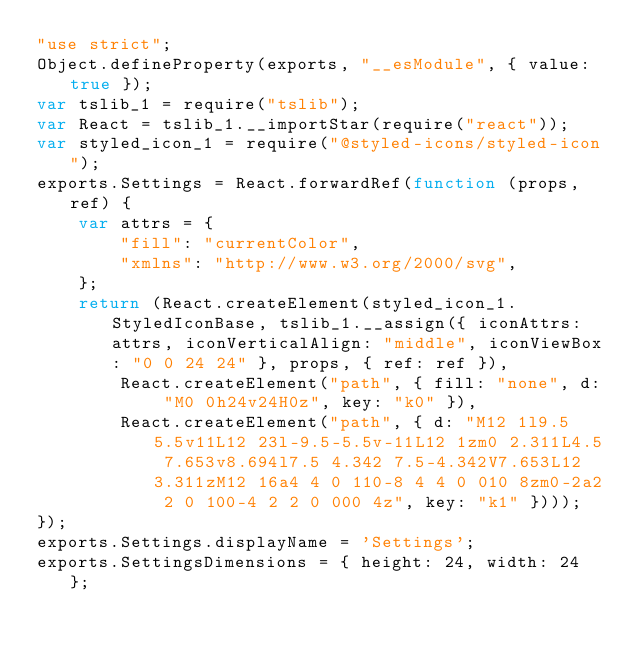Convert code to text. <code><loc_0><loc_0><loc_500><loc_500><_JavaScript_>"use strict";
Object.defineProperty(exports, "__esModule", { value: true });
var tslib_1 = require("tslib");
var React = tslib_1.__importStar(require("react"));
var styled_icon_1 = require("@styled-icons/styled-icon");
exports.Settings = React.forwardRef(function (props, ref) {
    var attrs = {
        "fill": "currentColor",
        "xmlns": "http://www.w3.org/2000/svg",
    };
    return (React.createElement(styled_icon_1.StyledIconBase, tslib_1.__assign({ iconAttrs: attrs, iconVerticalAlign: "middle", iconViewBox: "0 0 24 24" }, props, { ref: ref }),
        React.createElement("path", { fill: "none", d: "M0 0h24v24H0z", key: "k0" }),
        React.createElement("path", { d: "M12 1l9.5 5.5v11L12 23l-9.5-5.5v-11L12 1zm0 2.311L4.5 7.653v8.694l7.5 4.342 7.5-4.342V7.653L12 3.311zM12 16a4 4 0 110-8 4 4 0 010 8zm0-2a2 2 0 100-4 2 2 0 000 4z", key: "k1" })));
});
exports.Settings.displayName = 'Settings';
exports.SettingsDimensions = { height: 24, width: 24 };
</code> 